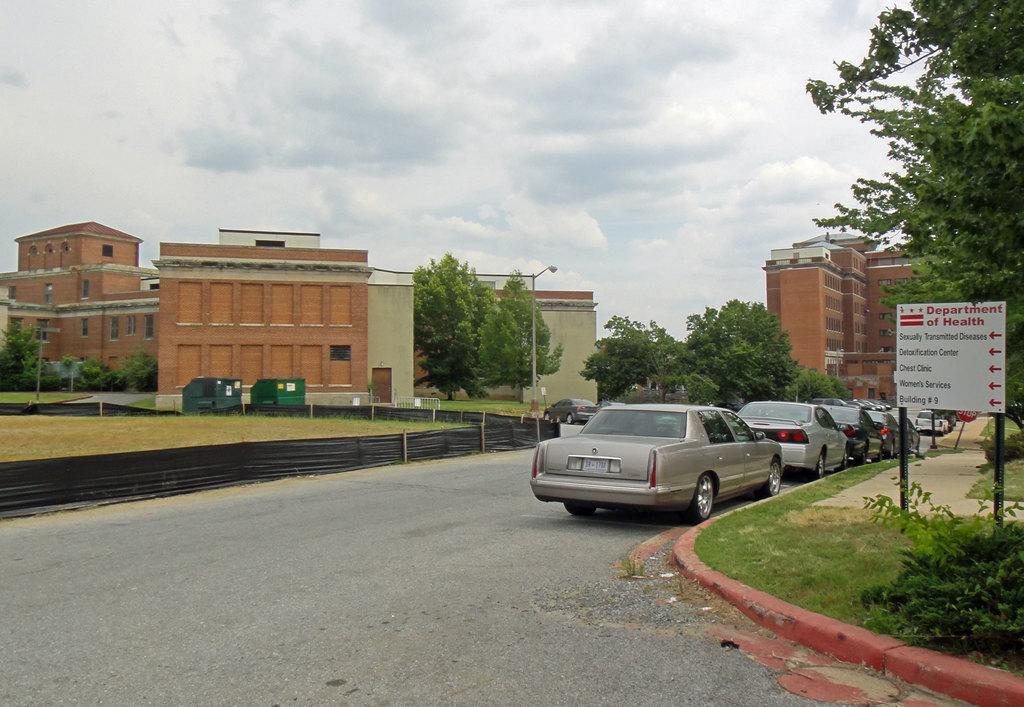Describe this image in one or two sentences. Here in this picture we can see number of cars present on the road over there and beside that we can see sign board present and we can see trees and plants here and there and we can see buildings also present all over there and we can see clouds in sky and we can see light post present here and there. 